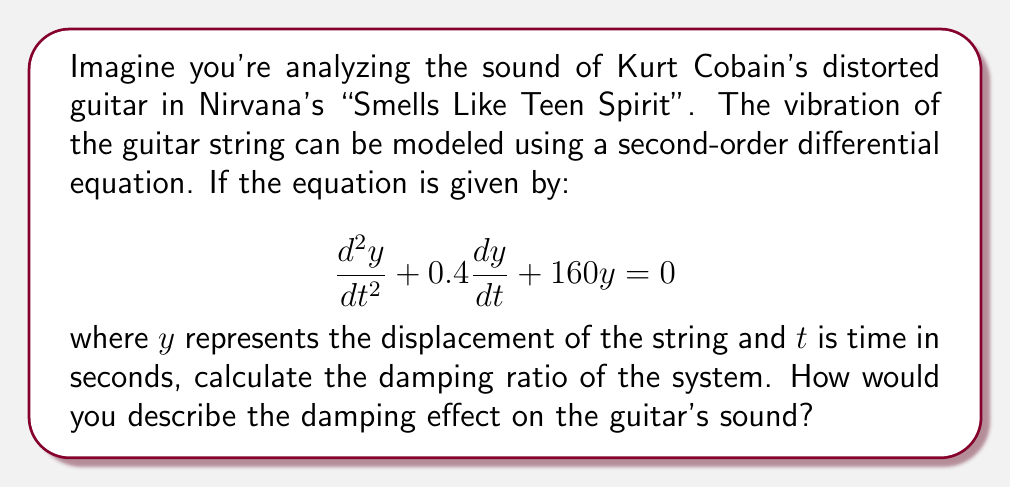Teach me how to tackle this problem. To solve this problem, we'll follow these steps:

1) The general form of a second-order linear differential equation is:

   $$\frac{d^2y}{dt^2} + 2\zeta\omega_n\frac{dy}{dt} + \omega_n^2y = 0$$

   where $\zeta$ is the damping ratio and $\omega_n$ is the natural frequency.

2) Comparing our equation to the general form, we can identify:

   $2\zeta\omega_n = 0.4$
   $\omega_n^2 = 160$

3) From $\omega_n^2 = 160$, we can calculate $\omega_n$:

   $\omega_n = \sqrt{160} = 4\sqrt{10} \approx 12.65$ rad/s

4) Now we can solve for $\zeta$:

   $\zeta = \frac{0.4}{2\omega_n} = \frac{0.4}{2(4\sqrt{10})} = \frac{0.1}{\sqrt{10}} \approx 0.0316$

5) To interpret this result:
   - If $\zeta < 1$, the system is underdamped
   - If $\zeta = 1$, the system is critically damped
   - If $\zeta > 1$, the system is overdamped

6) In this case, $\zeta \approx 0.0316 < 1$, so the system is underdamped.

For an underdamped system, the vibration will oscillate with decreasing amplitude over time. In terms of the guitar sound, this means the note will ring out and gradually fade away, which is typical for a guitar string. The low value of $\zeta$ indicates that the damping is relatively weak, allowing the note to sustain for a longer time, which is characteristic of the rich, sustained tones often heard in grunge music.
Answer: The damping ratio is $\zeta \approx 0.0316$. The system is underdamped, resulting in a sustained, gradually fading guitar sound typical of grunge music. 